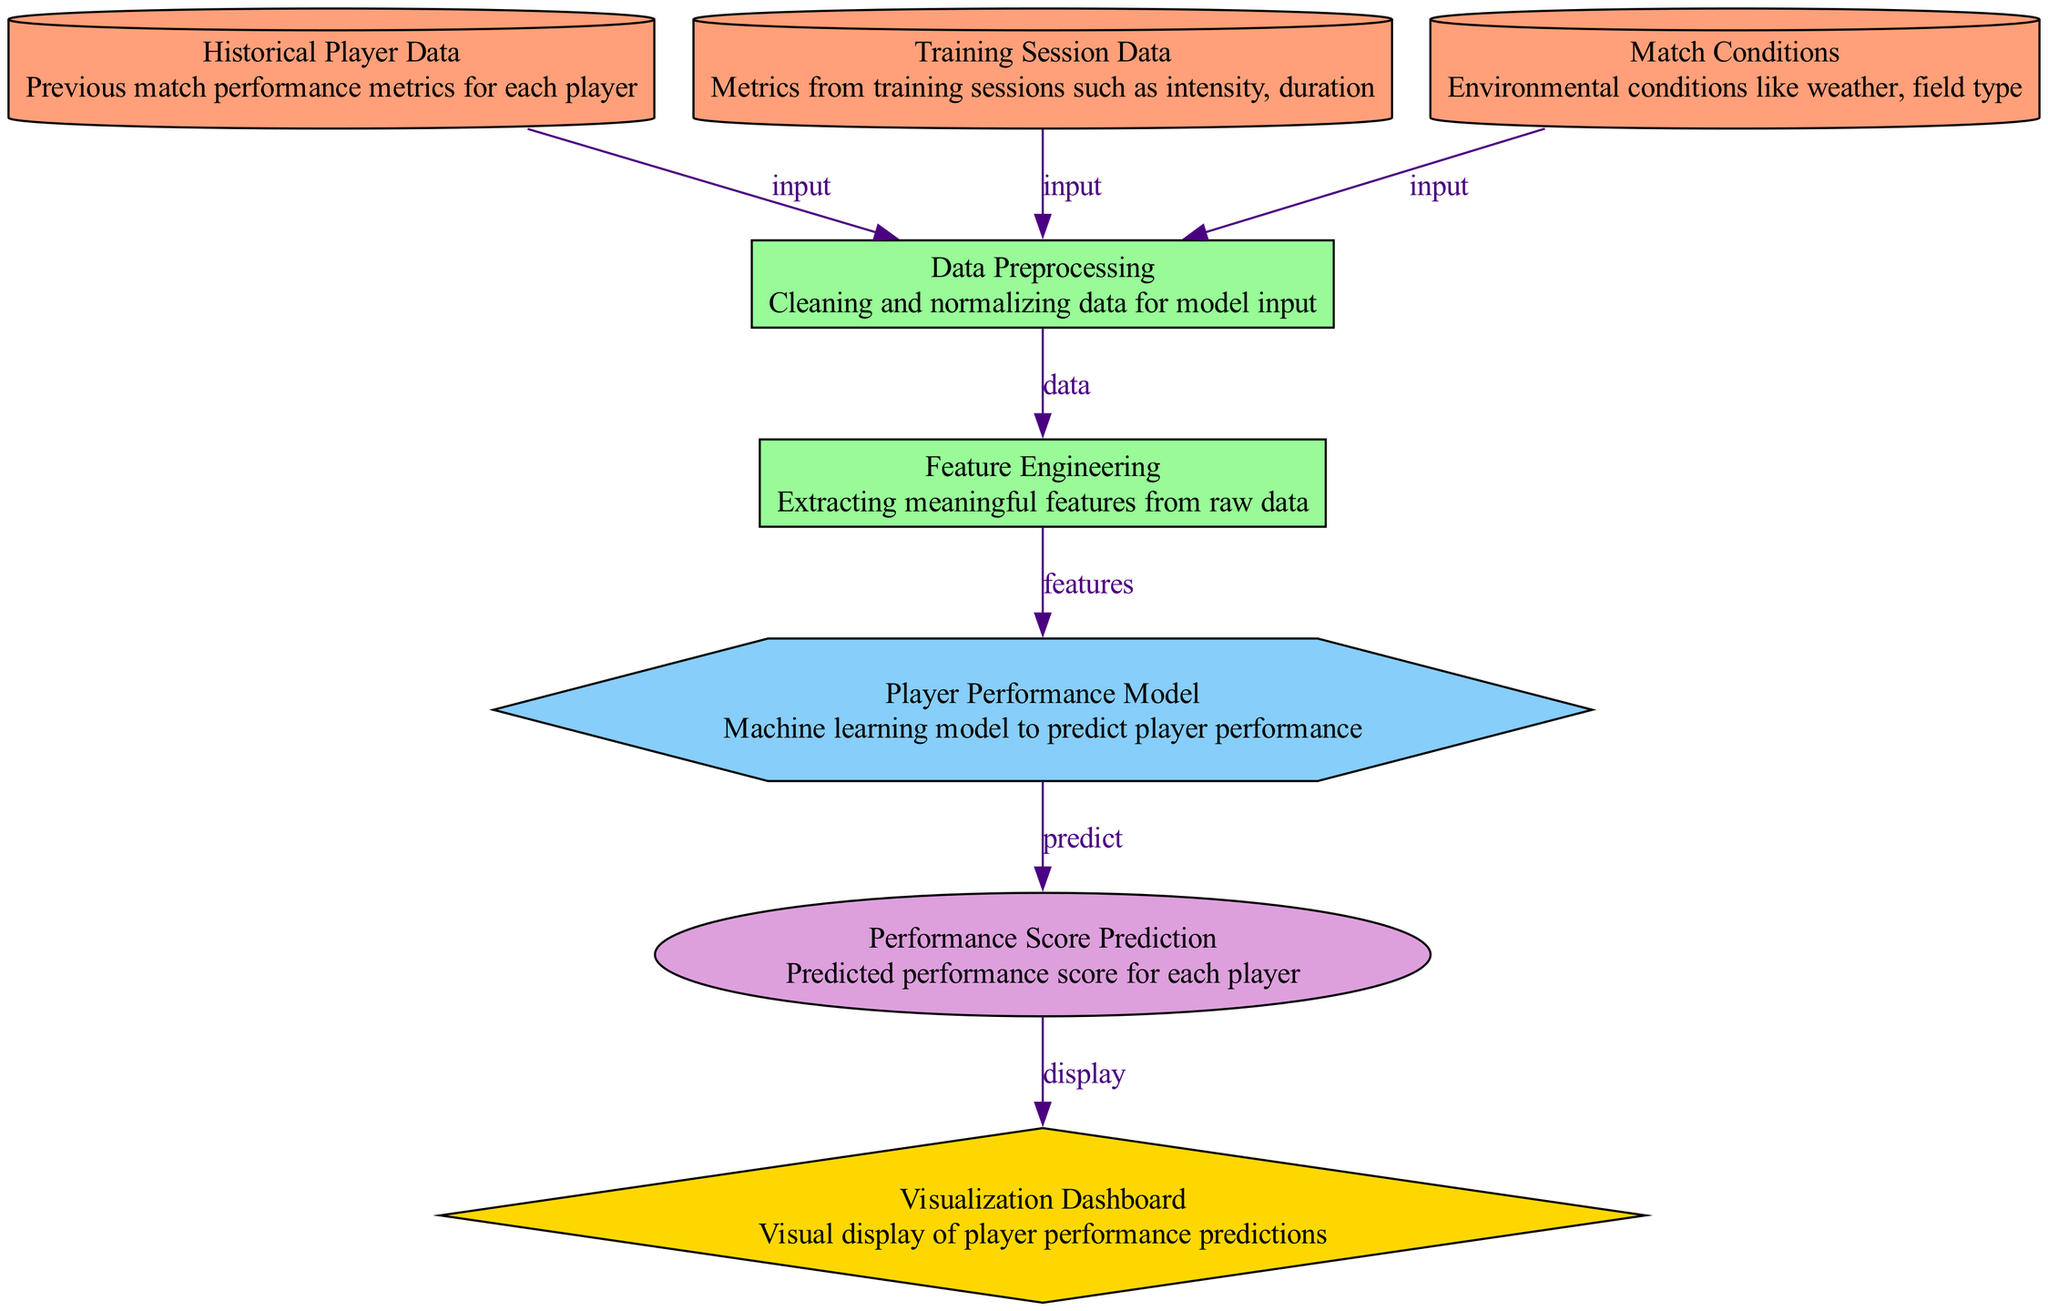What is the input data type connected to the Data Preprocessing node? The Data Preprocessing node takes input from three nodes: Historical Player Data, Training Session Data, and Match Conditions. Each of these nodes provides relevant input data for the preprocessing step.
Answer: data_source How many nodes are in the diagram? The diagram consists of a total of eight distinct nodes, which include data sources, processes, a model, an output, and a visualization.
Answer: eight What is the final output of the diagram? The final output of the diagram is the Performance Score Prediction, indicating the predicted performance score for each player based on the model's calculations.
Answer: Performance Score Prediction What connects the Data Preprocessing node to the Feature Engineering node? The Data Preprocessing node outputs processed data that is used as input for the Feature Engineering node to extract meaningful features from. This connection represents the flow of data from preprocessing to feature extraction.
Answer: data What is the role of the Player Performance Model in the diagram? The Player Performance Model serves as the core machine learning component that processes the extracted features to predict the individual players' performance scores. It plays a crucial role in transforming the engineered features into performance predictions.
Answer: predict Which node is responsible for visualizing the predictions? The Visualization Dashboard node is responsible for displaying the predicted performance scores visually. It takes the output from the Performance Score Prediction node and presents it in an easily interpretable format for analysis.
Answer: Visualization Dashboard What type of data does the Training Session Data node provide? The Training Session Data node provides metrics from training sessions, specifically focusing on aspects such as intensity and duration that influence player performance.
Answer: metrics What kind of processes occur after Data Preprocessing? Following Data Preprocessing, the process of Feature Engineering occurs, which involves selecting and extracting significant features from the preprocessed data to enhance the predictive capabilities of the subsequent model.
Answer: Feature Engineering 